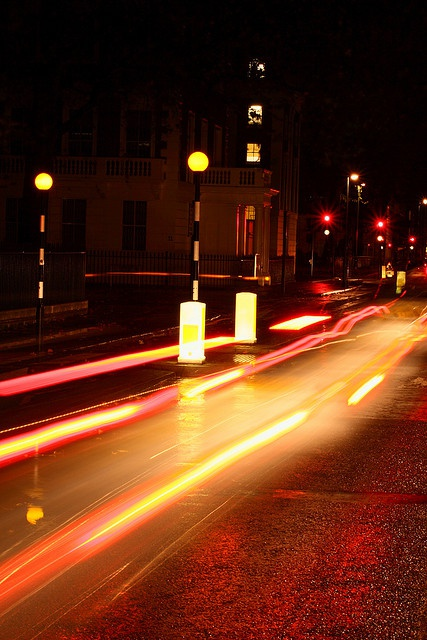Describe the objects in this image and their specific colors. I can see traffic light in black, maroon, and red tones, traffic light in black, red, maroon, and white tones, traffic light in black, red, and maroon tones, traffic light in black, maroon, and white tones, and traffic light in black, maroon, red, and brown tones in this image. 